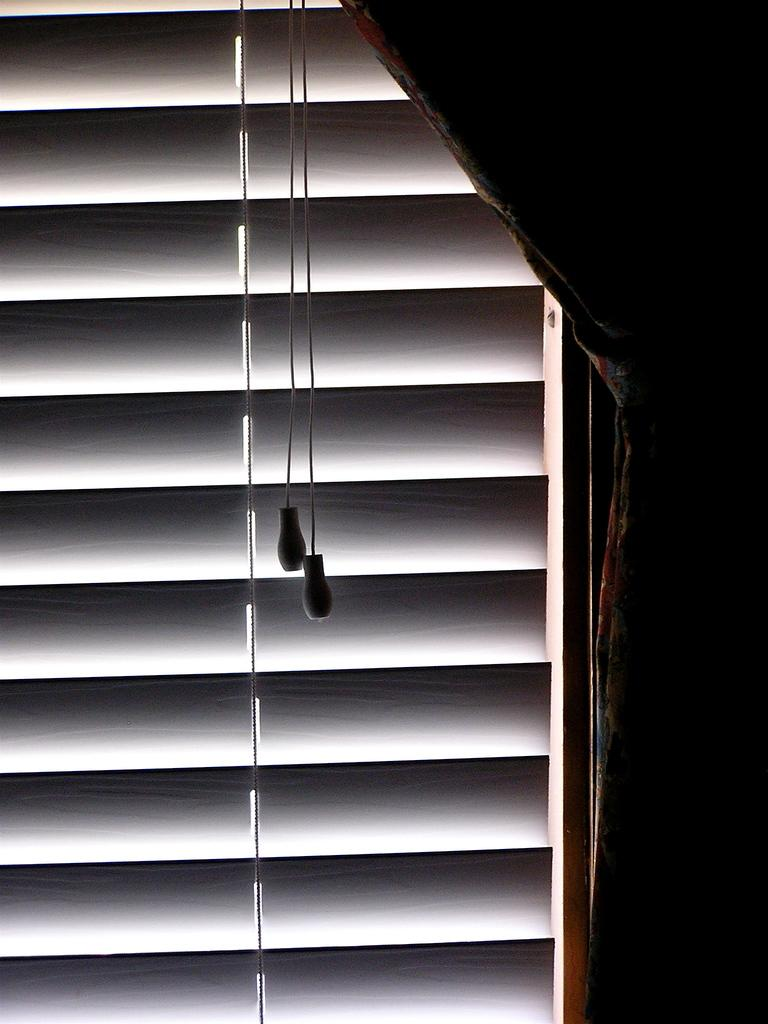What is located on the right side of the image? There is a curtain on the right side of the image. What type of architectural feature is present in the image? There is a window door in the image. Can you describe the objects attached to the threads in the image? Unfortunately, the facts provided do not give any information about the objects attached to the threads. Is there a bomb visible in the image? No, there is no bomb present in the image. What type of bread can be seen resting on the window sill in the image? There is no bread visible in the image. 